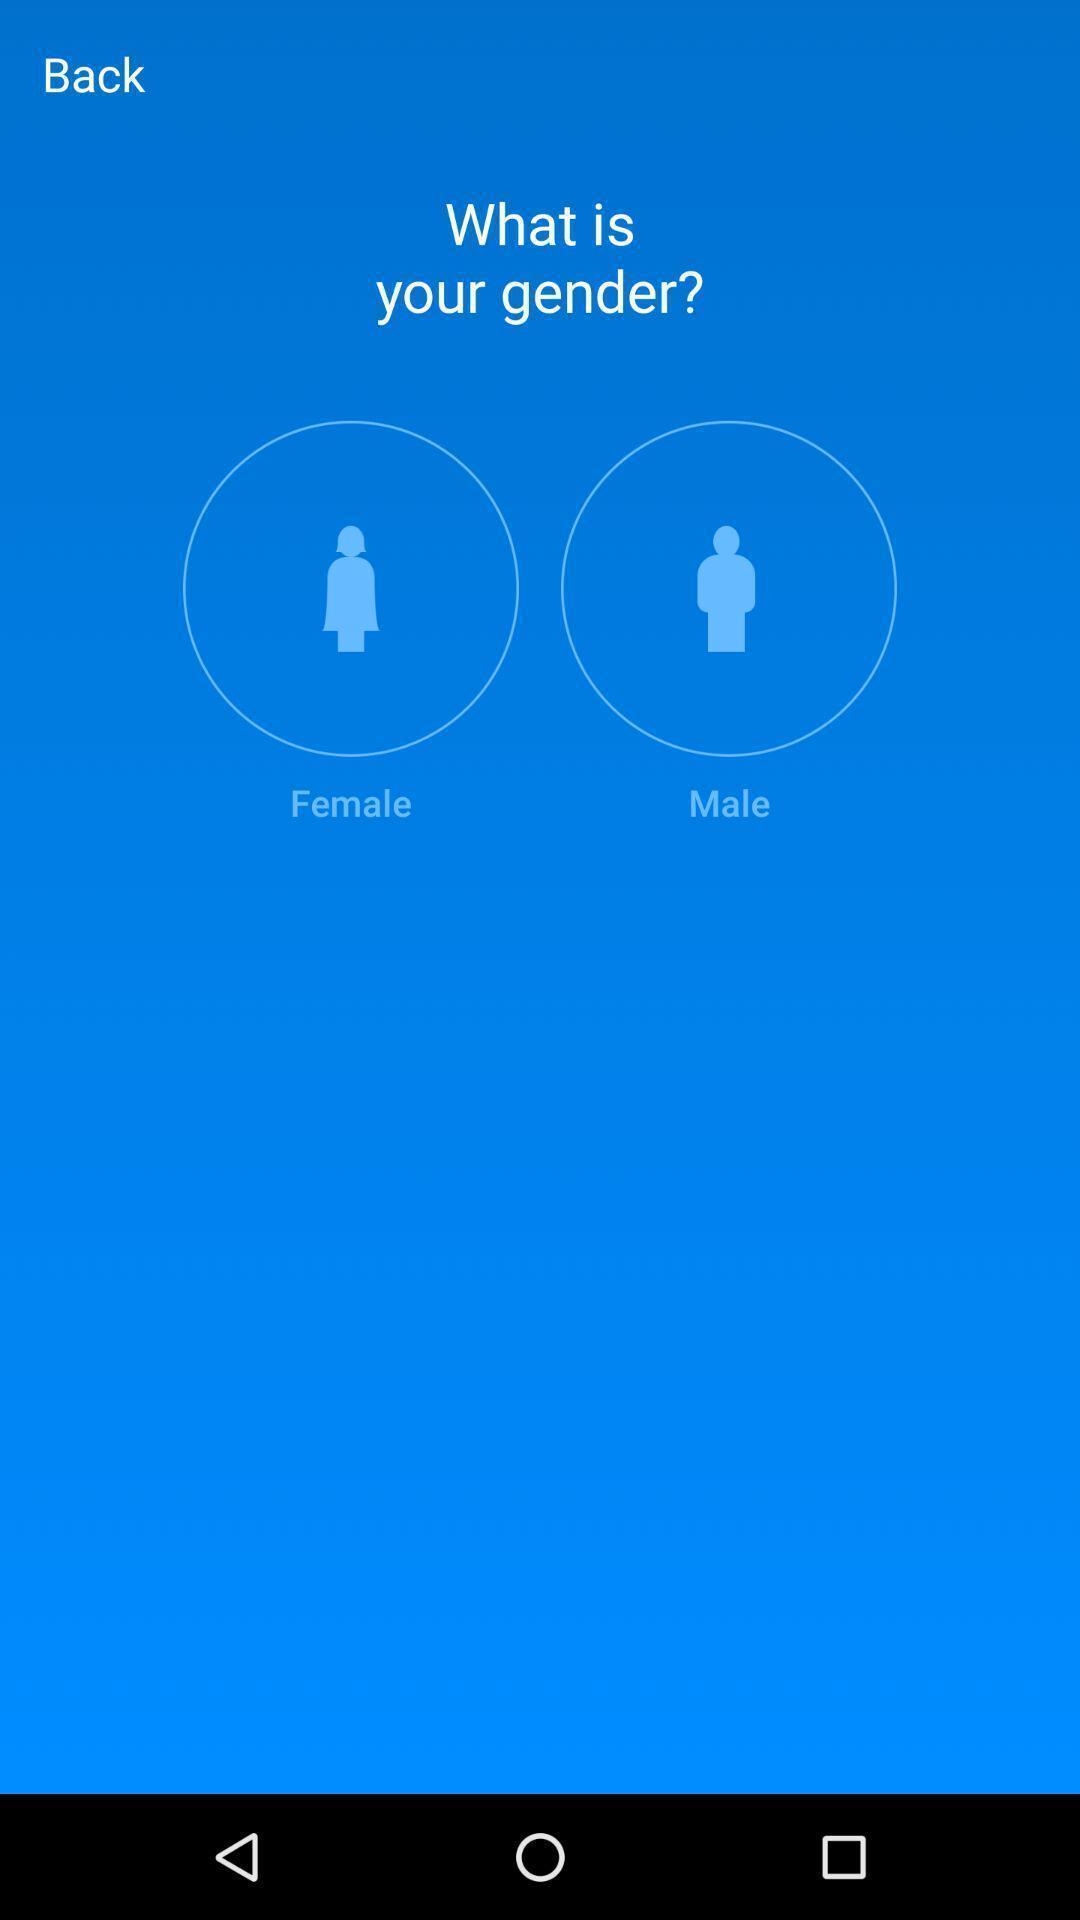Provide a detailed account of this screenshot. Page displaying female and male icons. 